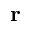<formula> <loc_0><loc_0><loc_500><loc_500>r</formula> 